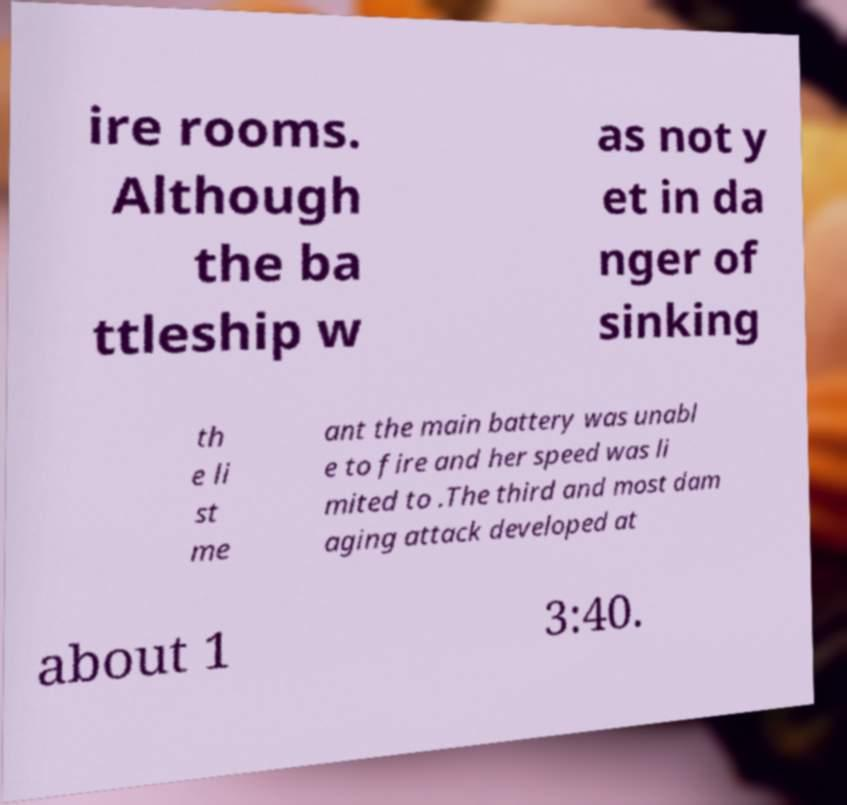What messages or text are displayed in this image? I need them in a readable, typed format. ire rooms. Although the ba ttleship w as not y et in da nger of sinking th e li st me ant the main battery was unabl e to fire and her speed was li mited to .The third and most dam aging attack developed at about 1 3:40. 